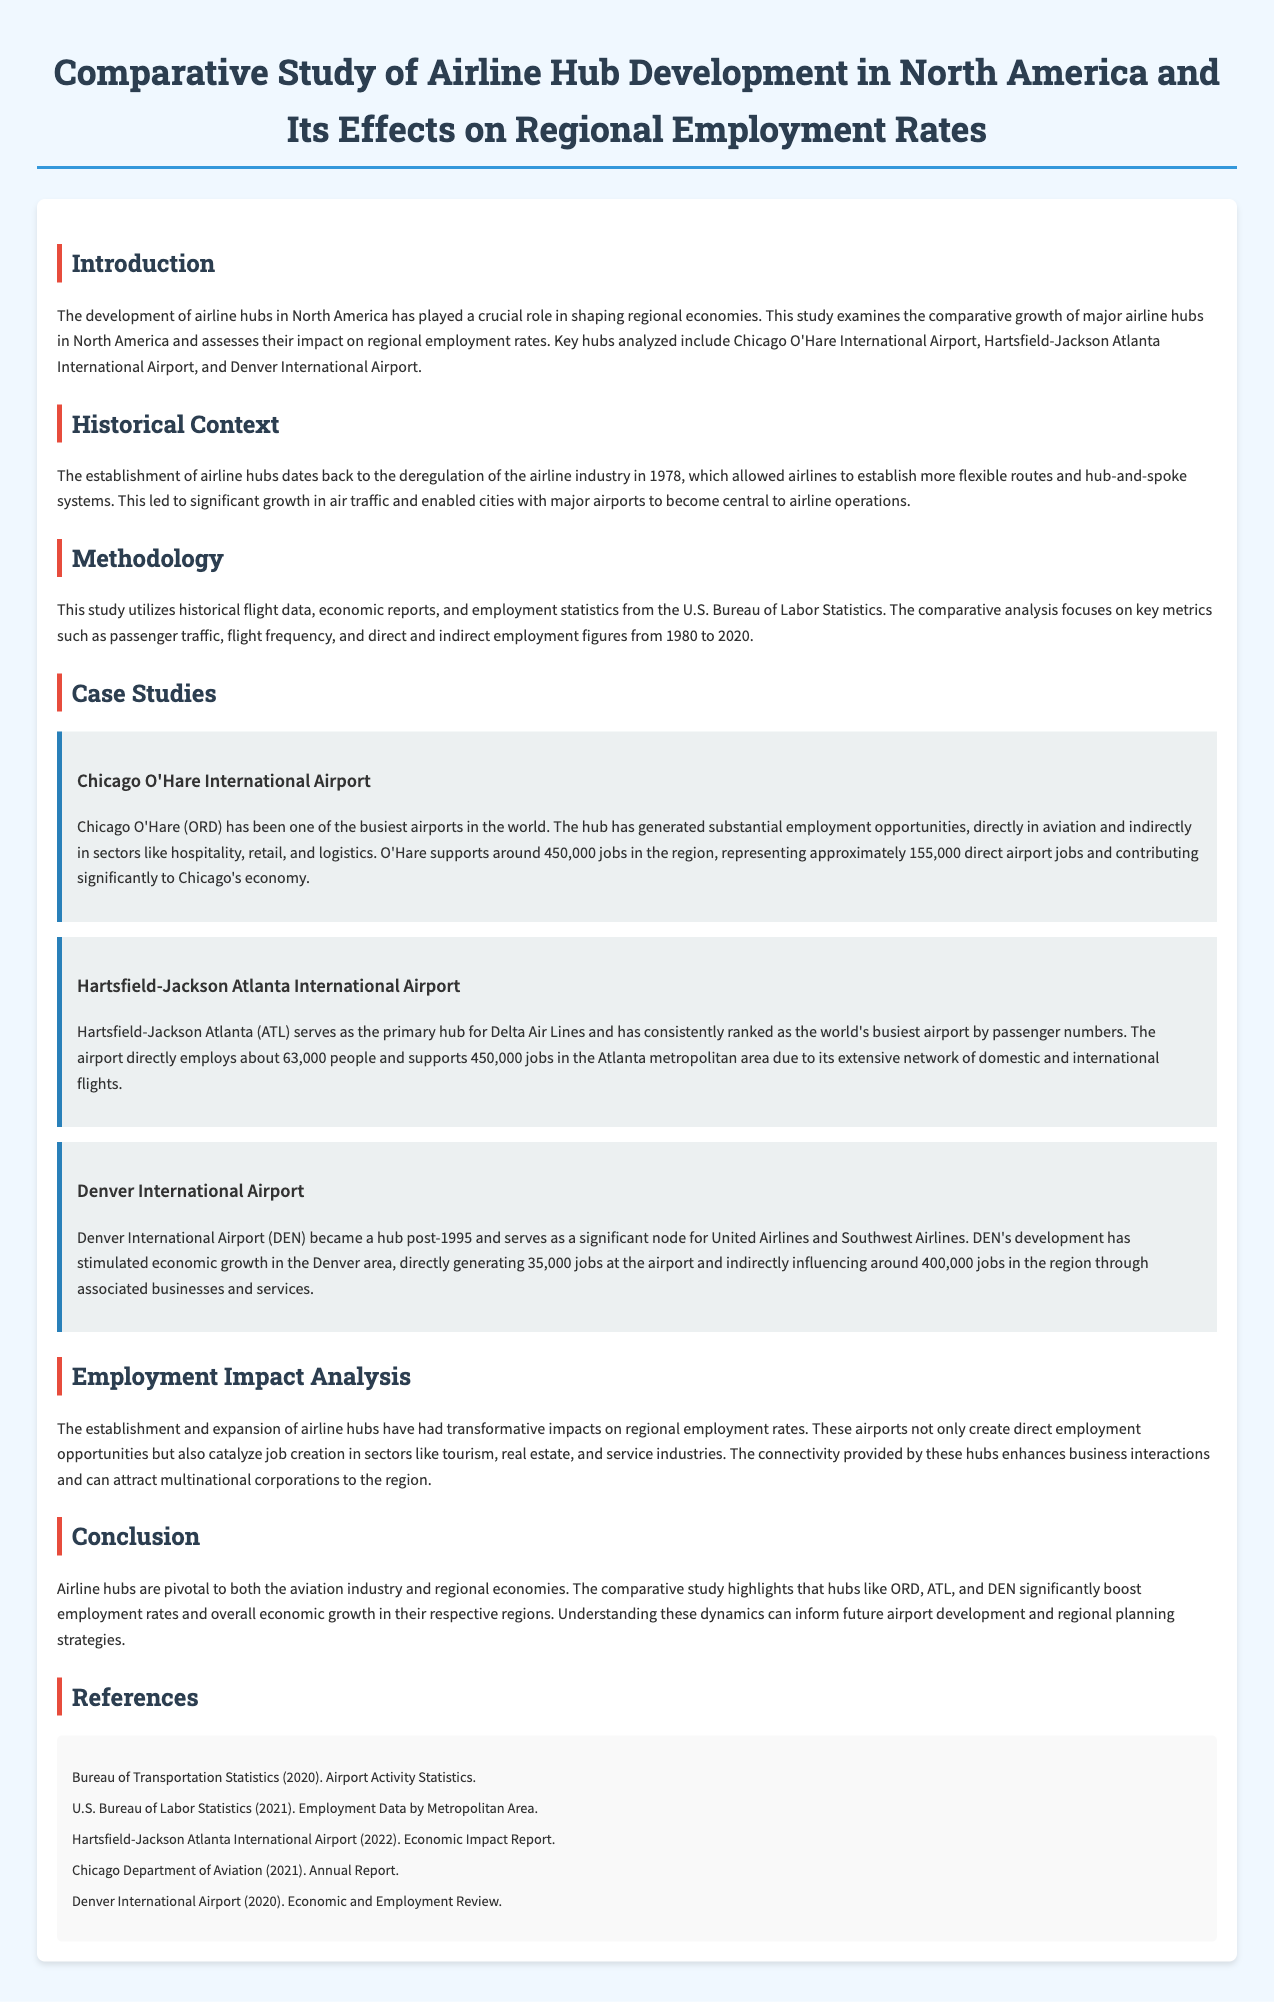What is the title of the document? The title of the document is stated prominently at the top of the rendered page.
Answer: Comparative Study of Airline Hub Development in North America and Its Effects on Regional Employment Rates Which airport is mentioned as having approximately 63,000 direct employees? The document includes specific information about employment figures for each airport discussed in the case studies.
Answer: Hartsfield-Jackson Atlanta International Airport What year marks the deregulation of the airline industry in the United States? The introduction section provides the historical context for airline hub development, specifying the year.
Answer: 1978 How many jobs does O'Hare International Airport support in the region? The case study on Chicago O'Hare International Airport states the total jobs supported by the airport.
Answer: 450,000 What is the time range of the employment statistics analyzed in the study? The methodology section indicates the specific years covered in the employment statistics.
Answer: 1980 to 2020 Which airline primarily operates from Hartsfield-Jackson Atlanta International Airport? The document mentions the main airline associated with the Atlanta hub in the case study.
Answer: Delta Air Lines How many direct jobs are created by Denver International Airport? The employment impact information in the case study for Denver provides direct job figures.
Answer: 35,000 What kind of analysis does the document perform? The overall purpose of the document is detailed in the introduction, describing the form of analysis conducted on the hubs.
Answer: Comparative analysis 